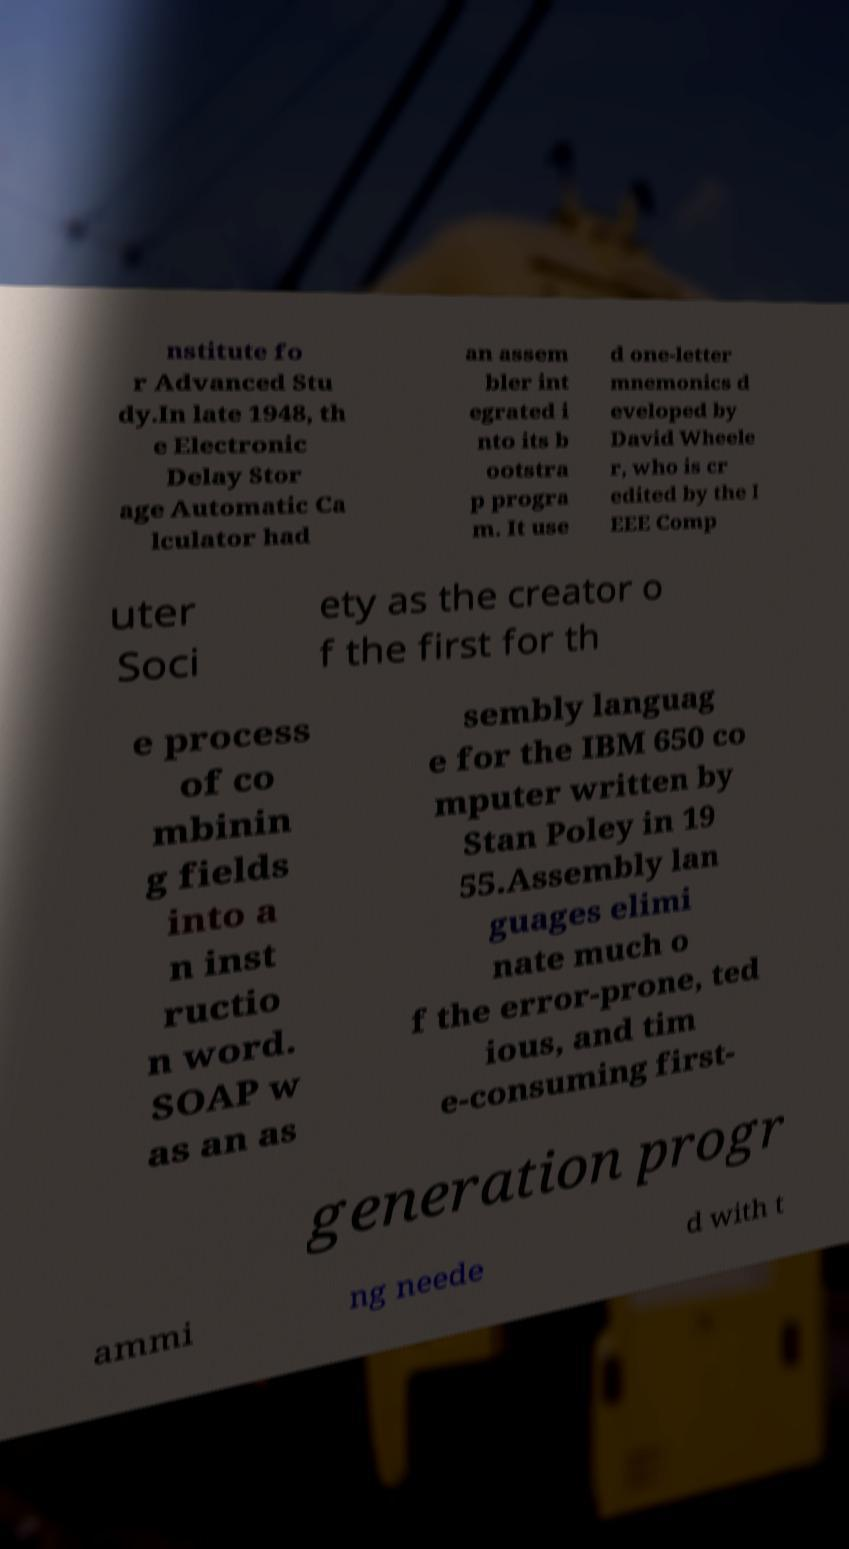Please read and relay the text visible in this image. What does it say? nstitute fo r Advanced Stu dy.In late 1948, th e Electronic Delay Stor age Automatic Ca lculator had an assem bler int egrated i nto its b ootstra p progra m. It use d one-letter mnemonics d eveloped by David Wheele r, who is cr edited by the I EEE Comp uter Soci ety as the creator o f the first for th e process of co mbinin g fields into a n inst ructio n word. SOAP w as an as sembly languag e for the IBM 650 co mputer written by Stan Poley in 19 55.Assembly lan guages elimi nate much o f the error-prone, ted ious, and tim e-consuming first- generation progr ammi ng neede d with t 